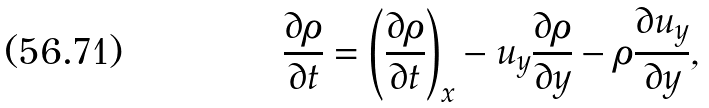<formula> <loc_0><loc_0><loc_500><loc_500>\frac { \partial \rho } { \partial t } = \left ( \frac { \partial \rho } { \partial t } \right ) _ { x } - u _ { y } \frac { \partial \rho } { \partial y } - \rho \frac { \partial u _ { y } } { \partial y } ,</formula> 